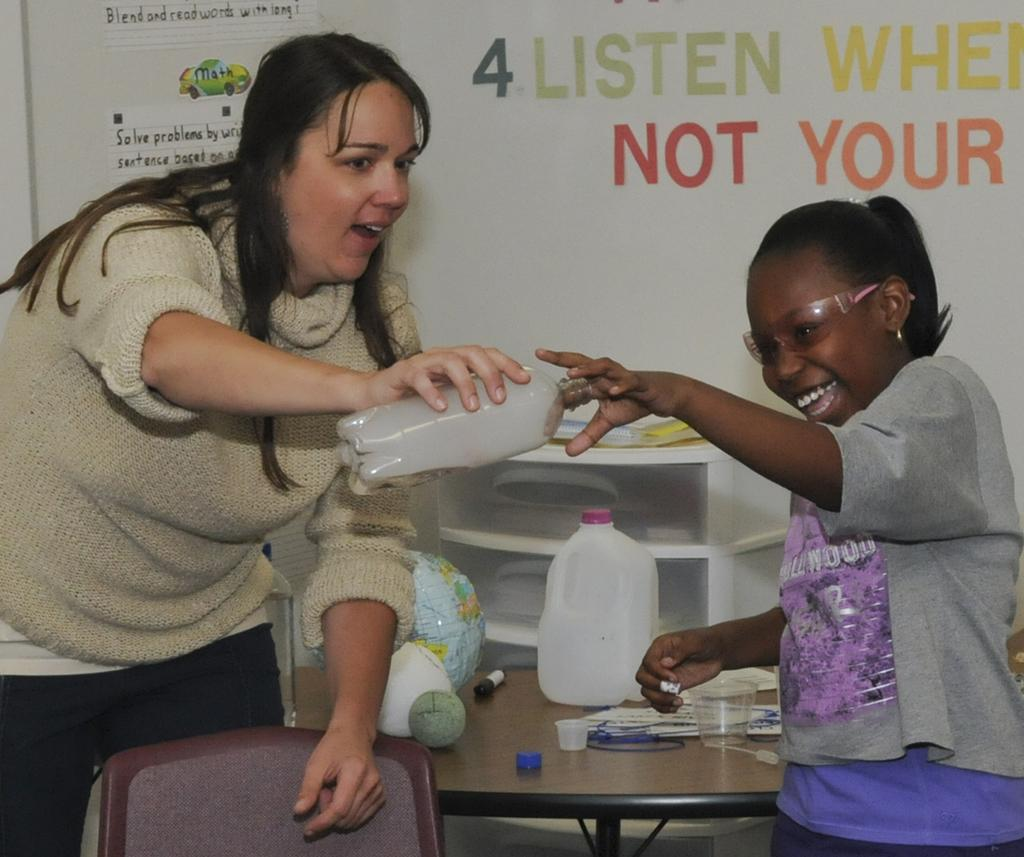Who is present in the image? There is a woman and a girl in the image. What are the woman and the girl holding? They are holding a water bottle. What can be seen on the table in the image? There are papers, a glass, and a gallon bottle on the table. What is on the wall in the image? There is a poster on the wall. What type of sock is the horse wearing in the image? There is no horse present in the image, and therefore no sock or any horse-related items can be observed. 